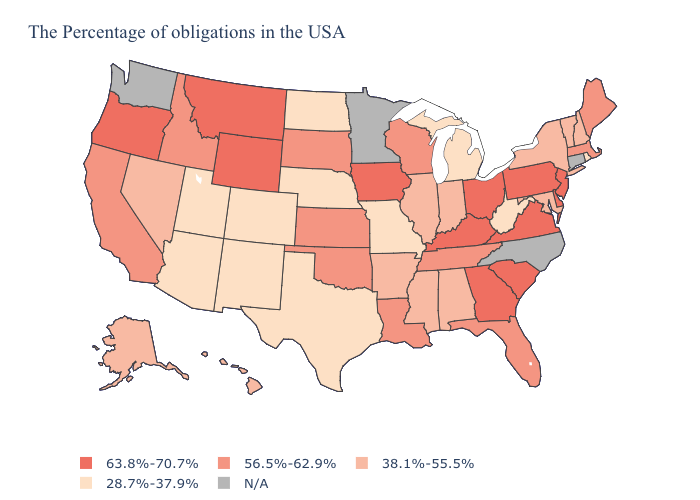What is the lowest value in states that border West Virginia?
Keep it brief. 38.1%-55.5%. Which states have the lowest value in the Northeast?
Answer briefly. Rhode Island. Name the states that have a value in the range 28.7%-37.9%?
Write a very short answer. Rhode Island, West Virginia, Michigan, Missouri, Nebraska, Texas, North Dakota, Colorado, New Mexico, Utah, Arizona. Among the states that border Virginia , does West Virginia have the lowest value?
Quick response, please. Yes. Does Louisiana have the lowest value in the South?
Concise answer only. No. What is the highest value in the USA?
Answer briefly. 63.8%-70.7%. Does the first symbol in the legend represent the smallest category?
Concise answer only. No. Name the states that have a value in the range 38.1%-55.5%?
Short answer required. New Hampshire, Vermont, New York, Maryland, Indiana, Alabama, Illinois, Mississippi, Arkansas, Nevada, Alaska, Hawaii. Is the legend a continuous bar?
Write a very short answer. No. Name the states that have a value in the range 38.1%-55.5%?
Write a very short answer. New Hampshire, Vermont, New York, Maryland, Indiana, Alabama, Illinois, Mississippi, Arkansas, Nevada, Alaska, Hawaii. What is the value of Ohio?
Concise answer only. 63.8%-70.7%. Does Hawaii have the highest value in the West?
Quick response, please. No. 